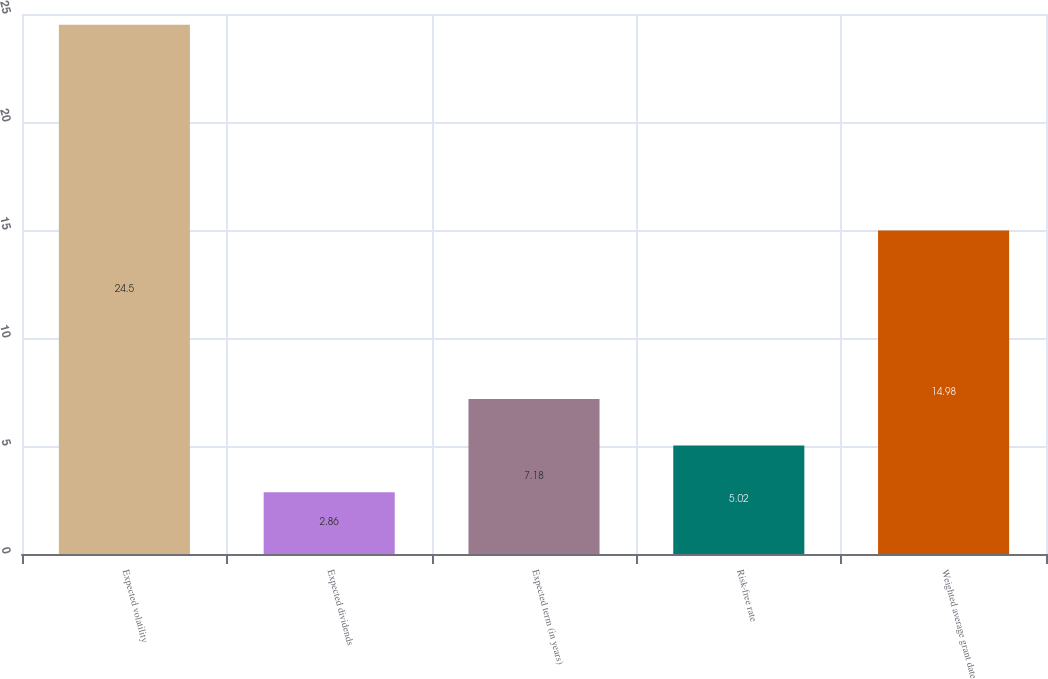Convert chart. <chart><loc_0><loc_0><loc_500><loc_500><bar_chart><fcel>Expected volatility<fcel>Expected dividends<fcel>Expected term (in years)<fcel>Risk-free rate<fcel>Weighted average grant date<nl><fcel>24.5<fcel>2.86<fcel>7.18<fcel>5.02<fcel>14.98<nl></chart> 